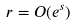<formula> <loc_0><loc_0><loc_500><loc_500>r = O ( e ^ { s } )</formula> 